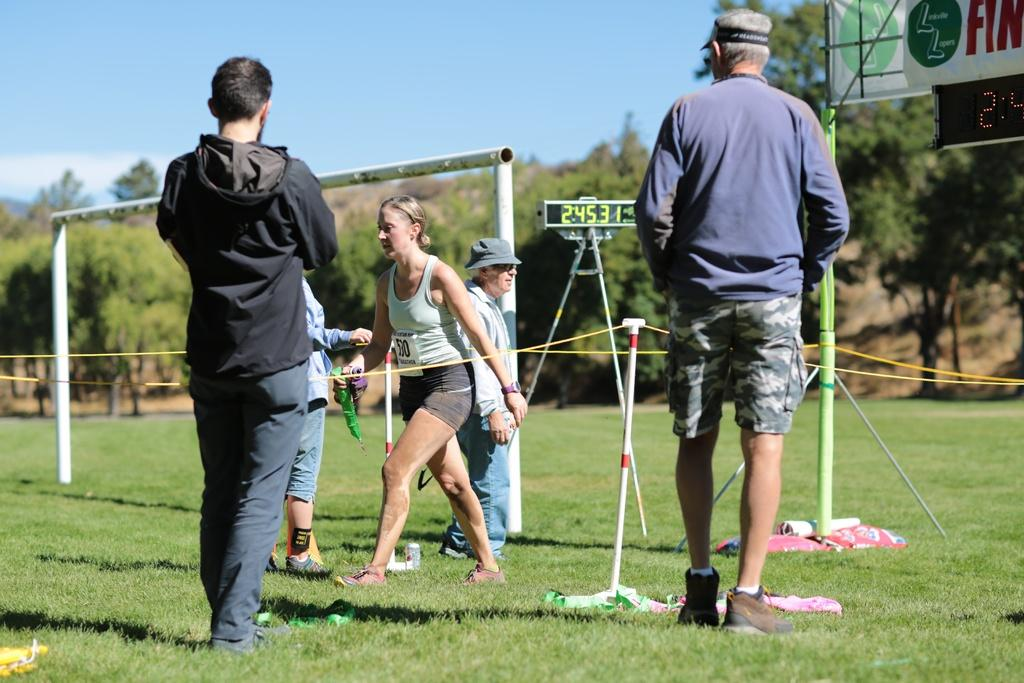<image>
Render a clear and concise summary of the photo. A runner with a number on her shirt walks near a digital display that reads 2:45.31. 